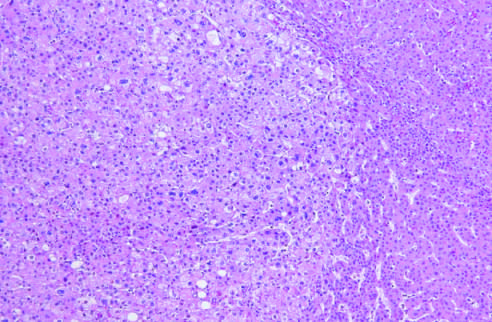did atrophy differentiate hepatocellular carcinoma within it?
Answer the question using a single word or phrase. No 